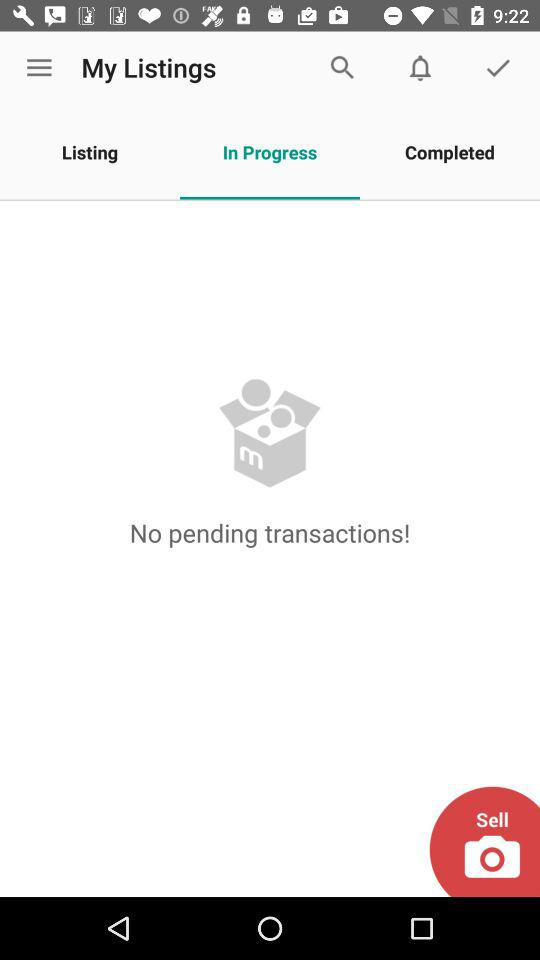What is the selected tab in "My Listings"? The selected tab is "In Progress". 